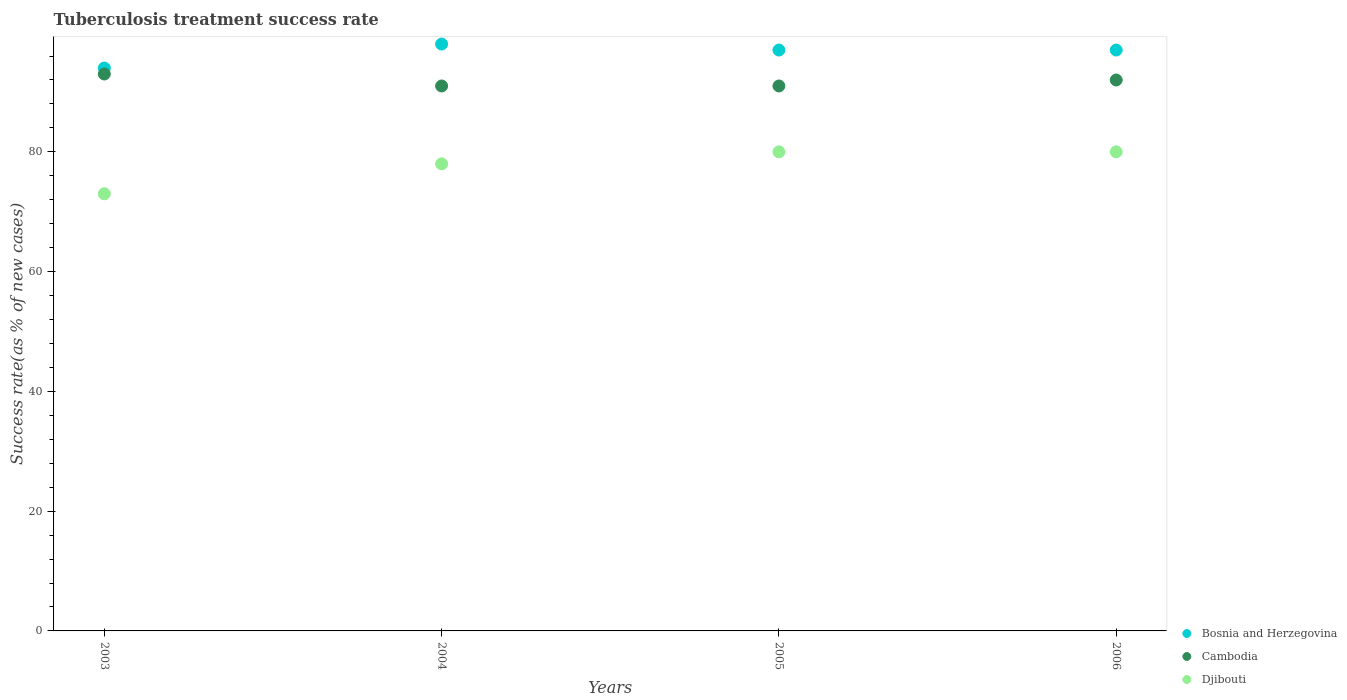How many different coloured dotlines are there?
Your answer should be very brief. 3. Is the number of dotlines equal to the number of legend labels?
Offer a very short reply. Yes. What is the tuberculosis treatment success rate in Bosnia and Herzegovina in 2003?
Your answer should be compact. 94. Across all years, what is the maximum tuberculosis treatment success rate in Bosnia and Herzegovina?
Give a very brief answer. 98. Across all years, what is the minimum tuberculosis treatment success rate in Bosnia and Herzegovina?
Make the answer very short. 94. In which year was the tuberculosis treatment success rate in Djibouti maximum?
Provide a succinct answer. 2005. What is the total tuberculosis treatment success rate in Djibouti in the graph?
Your answer should be very brief. 311. What is the difference between the tuberculosis treatment success rate in Bosnia and Herzegovina in 2003 and that in 2006?
Provide a succinct answer. -3. What is the difference between the tuberculosis treatment success rate in Djibouti in 2006 and the tuberculosis treatment success rate in Bosnia and Herzegovina in 2003?
Your answer should be very brief. -14. What is the average tuberculosis treatment success rate in Djibouti per year?
Your response must be concise. 77.75. In the year 2006, what is the difference between the tuberculosis treatment success rate in Djibouti and tuberculosis treatment success rate in Cambodia?
Keep it short and to the point. -12. In how many years, is the tuberculosis treatment success rate in Djibouti greater than 60 %?
Offer a terse response. 4. What is the ratio of the tuberculosis treatment success rate in Cambodia in 2003 to that in 2006?
Your answer should be compact. 1.01. Is the difference between the tuberculosis treatment success rate in Djibouti in 2003 and 2004 greater than the difference between the tuberculosis treatment success rate in Cambodia in 2003 and 2004?
Your response must be concise. No. What is the difference between the highest and the lowest tuberculosis treatment success rate in Cambodia?
Make the answer very short. 2. Is the sum of the tuberculosis treatment success rate in Cambodia in 2004 and 2005 greater than the maximum tuberculosis treatment success rate in Djibouti across all years?
Provide a succinct answer. Yes. Is it the case that in every year, the sum of the tuberculosis treatment success rate in Cambodia and tuberculosis treatment success rate in Bosnia and Herzegovina  is greater than the tuberculosis treatment success rate in Djibouti?
Provide a short and direct response. Yes. Does the tuberculosis treatment success rate in Djibouti monotonically increase over the years?
Keep it short and to the point. No. How many dotlines are there?
Offer a very short reply. 3. How many years are there in the graph?
Your answer should be compact. 4. What is the difference between two consecutive major ticks on the Y-axis?
Keep it short and to the point. 20. Are the values on the major ticks of Y-axis written in scientific E-notation?
Provide a short and direct response. No. Does the graph contain any zero values?
Your answer should be very brief. No. Does the graph contain grids?
Your response must be concise. No. Where does the legend appear in the graph?
Offer a very short reply. Bottom right. What is the title of the graph?
Offer a very short reply. Tuberculosis treatment success rate. Does "Myanmar" appear as one of the legend labels in the graph?
Your answer should be compact. No. What is the label or title of the X-axis?
Your answer should be very brief. Years. What is the label or title of the Y-axis?
Your response must be concise. Success rate(as % of new cases). What is the Success rate(as % of new cases) of Bosnia and Herzegovina in 2003?
Your answer should be compact. 94. What is the Success rate(as % of new cases) of Cambodia in 2003?
Keep it short and to the point. 93. What is the Success rate(as % of new cases) in Bosnia and Herzegovina in 2004?
Your answer should be compact. 98. What is the Success rate(as % of new cases) in Cambodia in 2004?
Your answer should be very brief. 91. What is the Success rate(as % of new cases) of Djibouti in 2004?
Your response must be concise. 78. What is the Success rate(as % of new cases) of Bosnia and Herzegovina in 2005?
Ensure brevity in your answer.  97. What is the Success rate(as % of new cases) of Cambodia in 2005?
Ensure brevity in your answer.  91. What is the Success rate(as % of new cases) of Bosnia and Herzegovina in 2006?
Make the answer very short. 97. What is the Success rate(as % of new cases) in Cambodia in 2006?
Provide a short and direct response. 92. Across all years, what is the maximum Success rate(as % of new cases) in Bosnia and Herzegovina?
Ensure brevity in your answer.  98. Across all years, what is the maximum Success rate(as % of new cases) in Cambodia?
Ensure brevity in your answer.  93. Across all years, what is the minimum Success rate(as % of new cases) of Bosnia and Herzegovina?
Provide a succinct answer. 94. Across all years, what is the minimum Success rate(as % of new cases) of Cambodia?
Your response must be concise. 91. Across all years, what is the minimum Success rate(as % of new cases) in Djibouti?
Make the answer very short. 73. What is the total Success rate(as % of new cases) of Bosnia and Herzegovina in the graph?
Keep it short and to the point. 386. What is the total Success rate(as % of new cases) of Cambodia in the graph?
Keep it short and to the point. 367. What is the total Success rate(as % of new cases) of Djibouti in the graph?
Keep it short and to the point. 311. What is the difference between the Success rate(as % of new cases) in Djibouti in 2003 and that in 2004?
Your answer should be very brief. -5. What is the difference between the Success rate(as % of new cases) in Bosnia and Herzegovina in 2003 and that in 2005?
Make the answer very short. -3. What is the difference between the Success rate(as % of new cases) in Djibouti in 2003 and that in 2005?
Provide a short and direct response. -7. What is the difference between the Success rate(as % of new cases) in Cambodia in 2003 and that in 2006?
Offer a terse response. 1. What is the difference between the Success rate(as % of new cases) in Bosnia and Herzegovina in 2004 and that in 2005?
Ensure brevity in your answer.  1. What is the difference between the Success rate(as % of new cases) in Cambodia in 2004 and that in 2005?
Provide a short and direct response. 0. What is the difference between the Success rate(as % of new cases) of Cambodia in 2004 and that in 2006?
Offer a very short reply. -1. What is the difference between the Success rate(as % of new cases) in Cambodia in 2005 and that in 2006?
Your answer should be compact. -1. What is the difference between the Success rate(as % of new cases) of Bosnia and Herzegovina in 2003 and the Success rate(as % of new cases) of Cambodia in 2004?
Your answer should be very brief. 3. What is the difference between the Success rate(as % of new cases) in Bosnia and Herzegovina in 2003 and the Success rate(as % of new cases) in Djibouti in 2004?
Offer a terse response. 16. What is the difference between the Success rate(as % of new cases) of Cambodia in 2003 and the Success rate(as % of new cases) of Djibouti in 2004?
Offer a terse response. 15. What is the difference between the Success rate(as % of new cases) in Bosnia and Herzegovina in 2003 and the Success rate(as % of new cases) in Djibouti in 2005?
Give a very brief answer. 14. What is the difference between the Success rate(as % of new cases) of Cambodia in 2003 and the Success rate(as % of new cases) of Djibouti in 2005?
Provide a succinct answer. 13. What is the difference between the Success rate(as % of new cases) of Bosnia and Herzegovina in 2003 and the Success rate(as % of new cases) of Cambodia in 2006?
Your answer should be very brief. 2. What is the difference between the Success rate(as % of new cases) in Bosnia and Herzegovina in 2004 and the Success rate(as % of new cases) in Cambodia in 2006?
Provide a succinct answer. 6. What is the difference between the Success rate(as % of new cases) in Bosnia and Herzegovina in 2005 and the Success rate(as % of new cases) in Cambodia in 2006?
Keep it short and to the point. 5. What is the difference between the Success rate(as % of new cases) of Cambodia in 2005 and the Success rate(as % of new cases) of Djibouti in 2006?
Your answer should be compact. 11. What is the average Success rate(as % of new cases) in Bosnia and Herzegovina per year?
Offer a very short reply. 96.5. What is the average Success rate(as % of new cases) of Cambodia per year?
Your answer should be very brief. 91.75. What is the average Success rate(as % of new cases) of Djibouti per year?
Give a very brief answer. 77.75. In the year 2003, what is the difference between the Success rate(as % of new cases) of Bosnia and Herzegovina and Success rate(as % of new cases) of Djibouti?
Your answer should be compact. 21. In the year 2005, what is the difference between the Success rate(as % of new cases) of Bosnia and Herzegovina and Success rate(as % of new cases) of Djibouti?
Provide a short and direct response. 17. In the year 2006, what is the difference between the Success rate(as % of new cases) of Bosnia and Herzegovina and Success rate(as % of new cases) of Cambodia?
Offer a very short reply. 5. What is the ratio of the Success rate(as % of new cases) in Bosnia and Herzegovina in 2003 to that in 2004?
Provide a short and direct response. 0.96. What is the ratio of the Success rate(as % of new cases) in Djibouti in 2003 to that in 2004?
Your response must be concise. 0.94. What is the ratio of the Success rate(as % of new cases) of Bosnia and Herzegovina in 2003 to that in 2005?
Keep it short and to the point. 0.97. What is the ratio of the Success rate(as % of new cases) in Cambodia in 2003 to that in 2005?
Your answer should be compact. 1.02. What is the ratio of the Success rate(as % of new cases) in Djibouti in 2003 to that in 2005?
Make the answer very short. 0.91. What is the ratio of the Success rate(as % of new cases) in Bosnia and Herzegovina in 2003 to that in 2006?
Your answer should be very brief. 0.97. What is the ratio of the Success rate(as % of new cases) in Cambodia in 2003 to that in 2006?
Make the answer very short. 1.01. What is the ratio of the Success rate(as % of new cases) of Djibouti in 2003 to that in 2006?
Your response must be concise. 0.91. What is the ratio of the Success rate(as % of new cases) of Bosnia and Herzegovina in 2004 to that in 2005?
Give a very brief answer. 1.01. What is the ratio of the Success rate(as % of new cases) in Cambodia in 2004 to that in 2005?
Ensure brevity in your answer.  1. What is the ratio of the Success rate(as % of new cases) of Bosnia and Herzegovina in 2004 to that in 2006?
Offer a very short reply. 1.01. What is the ratio of the Success rate(as % of new cases) of Cambodia in 2004 to that in 2006?
Offer a terse response. 0.99. What is the ratio of the Success rate(as % of new cases) of Cambodia in 2005 to that in 2006?
Your response must be concise. 0.99. What is the difference between the highest and the second highest Success rate(as % of new cases) of Bosnia and Herzegovina?
Provide a succinct answer. 1. What is the difference between the highest and the second highest Success rate(as % of new cases) in Cambodia?
Your answer should be compact. 1. What is the difference between the highest and the second highest Success rate(as % of new cases) of Djibouti?
Offer a terse response. 0. What is the difference between the highest and the lowest Success rate(as % of new cases) in Bosnia and Herzegovina?
Ensure brevity in your answer.  4. What is the difference between the highest and the lowest Success rate(as % of new cases) of Cambodia?
Your answer should be compact. 2. What is the difference between the highest and the lowest Success rate(as % of new cases) in Djibouti?
Provide a succinct answer. 7. 